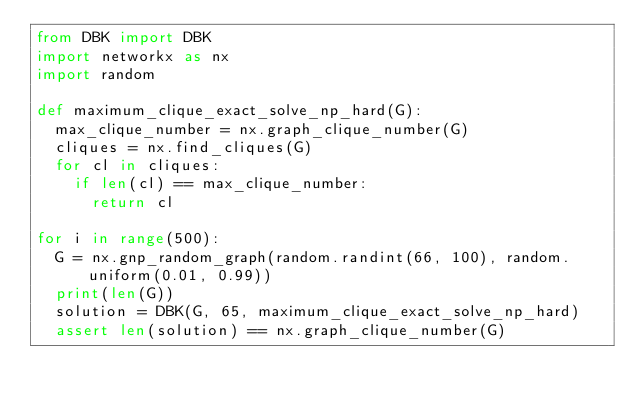Convert code to text. <code><loc_0><loc_0><loc_500><loc_500><_Python_>from DBK import DBK
import networkx as nx
import random

def maximum_clique_exact_solve_np_hard(G):
	max_clique_number = nx.graph_clique_number(G)
	cliques = nx.find_cliques(G)
	for cl in cliques:
		if len(cl) == max_clique_number:
			return cl

for i in range(500):
	G = nx.gnp_random_graph(random.randint(66, 100), random.uniform(0.01, 0.99))
	print(len(G))
	solution = DBK(G, 65, maximum_clique_exact_solve_np_hard)
	assert len(solution) == nx.graph_clique_number(G)
</code> 